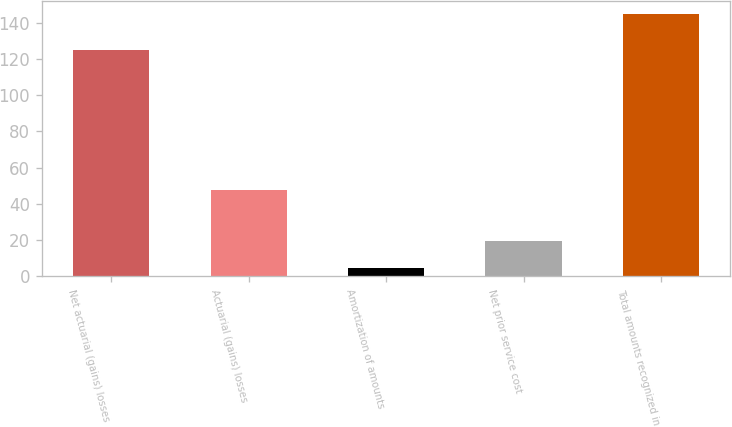Convert chart to OTSL. <chart><loc_0><loc_0><loc_500><loc_500><bar_chart><fcel>Net actuarial (gains) losses<fcel>Actuarial (gains) losses<fcel>Amortization of amounts<fcel>Net prior service cost<fcel>Total amounts recognized in<nl><fcel>125<fcel>47.58<fcel>4.6<fcel>19.6<fcel>144.5<nl></chart> 